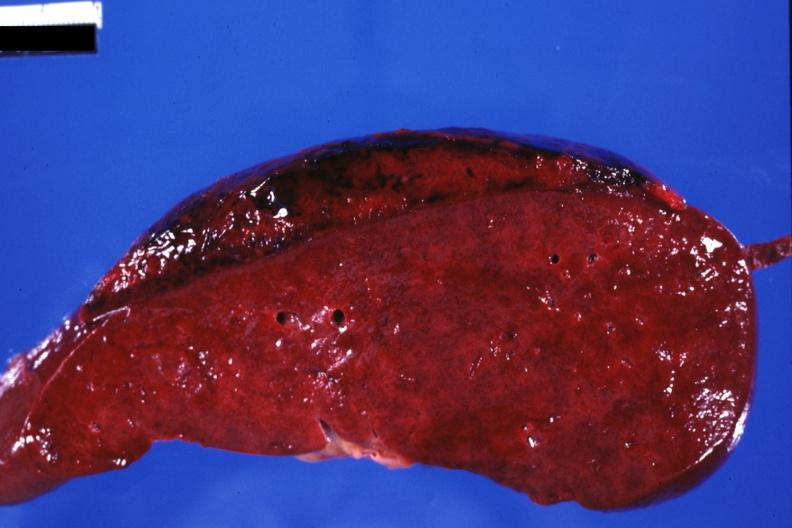where is this part in?
Answer the question using a single word or phrase. Spleen 